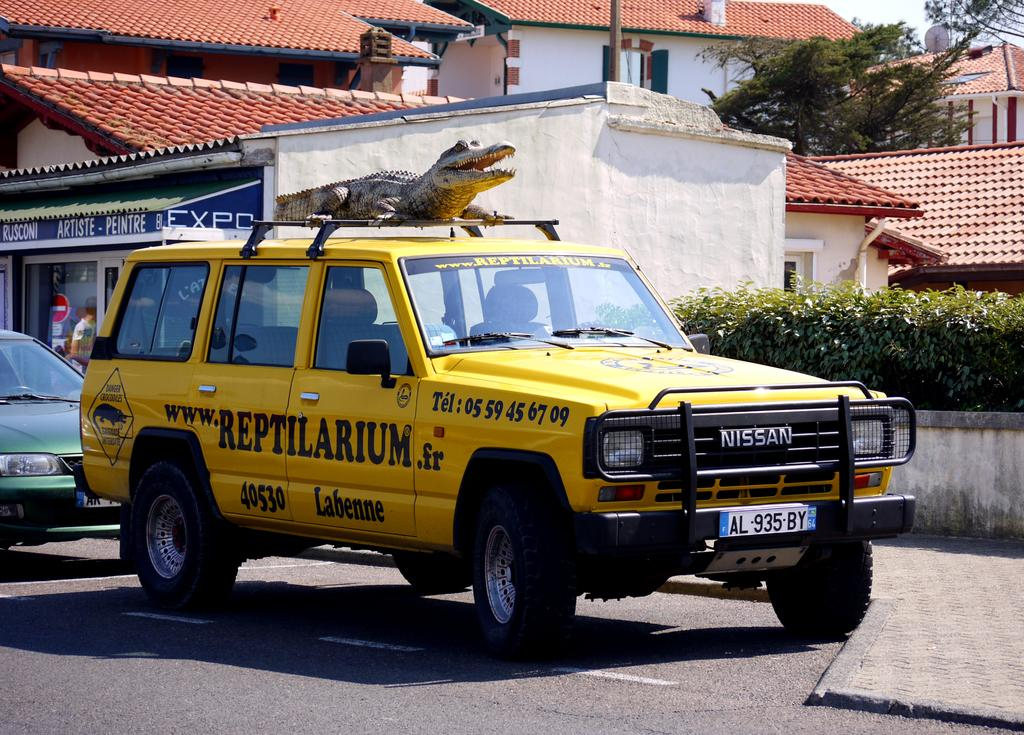<image>
Create a compact narrative representing the image presented. A yellow NISSAN vehicle has a fake alligator on the top of it and the website www.REPTILARIUM.fr on the side of it. 